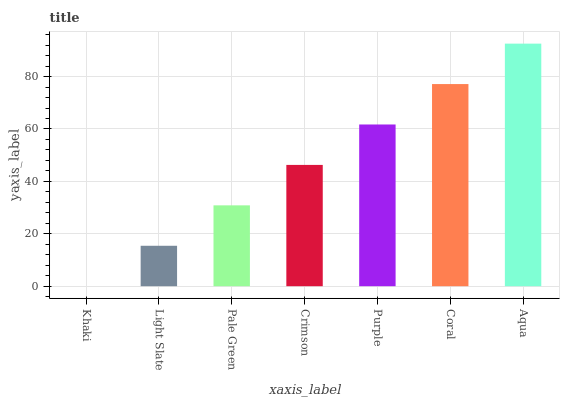Is Khaki the minimum?
Answer yes or no. Yes. Is Aqua the maximum?
Answer yes or no. Yes. Is Light Slate the minimum?
Answer yes or no. No. Is Light Slate the maximum?
Answer yes or no. No. Is Light Slate greater than Khaki?
Answer yes or no. Yes. Is Khaki less than Light Slate?
Answer yes or no. Yes. Is Khaki greater than Light Slate?
Answer yes or no. No. Is Light Slate less than Khaki?
Answer yes or no. No. Is Crimson the high median?
Answer yes or no. Yes. Is Crimson the low median?
Answer yes or no. Yes. Is Coral the high median?
Answer yes or no. No. Is Coral the low median?
Answer yes or no. No. 